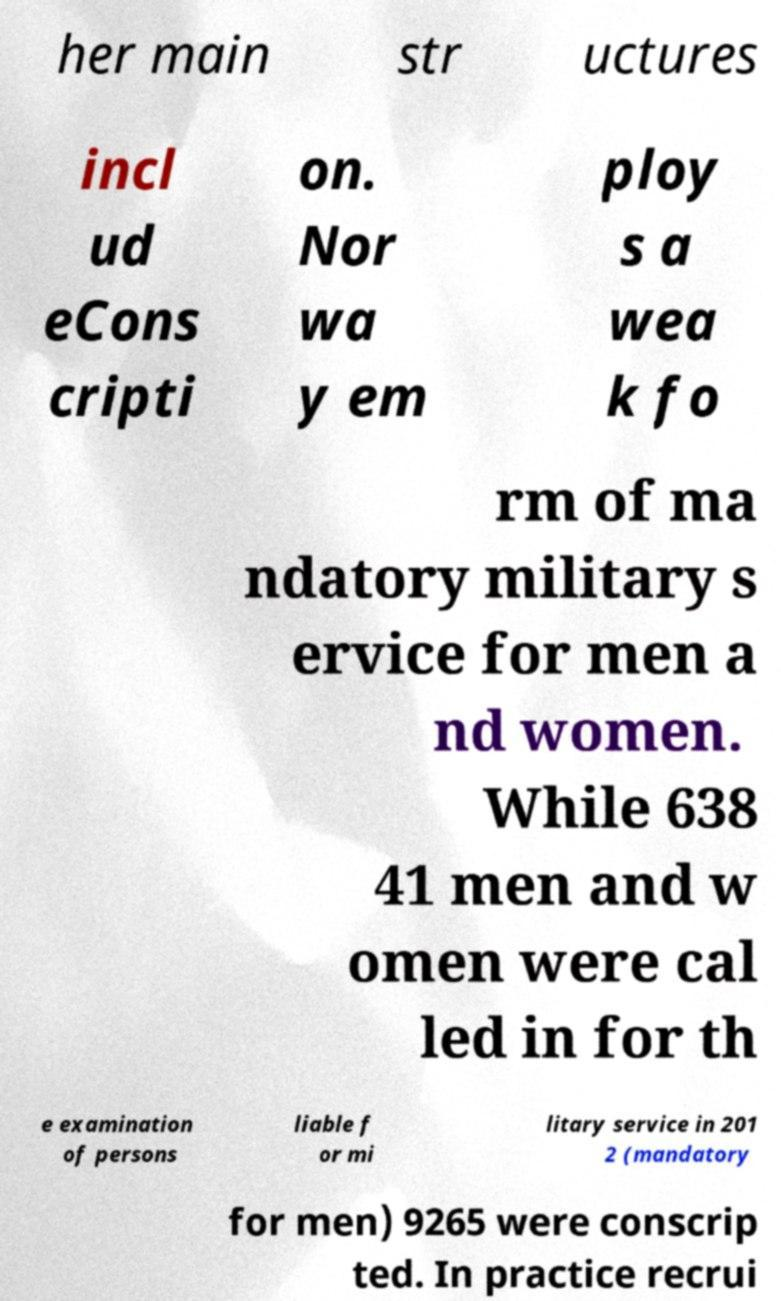Could you extract and type out the text from this image? her main str uctures incl ud eCons cripti on. Nor wa y em ploy s a wea k fo rm of ma ndatory military s ervice for men a nd women. While 638 41 men and w omen were cal led in for th e examination of persons liable f or mi litary service in 201 2 (mandatory for men) 9265 were conscrip ted. In practice recrui 